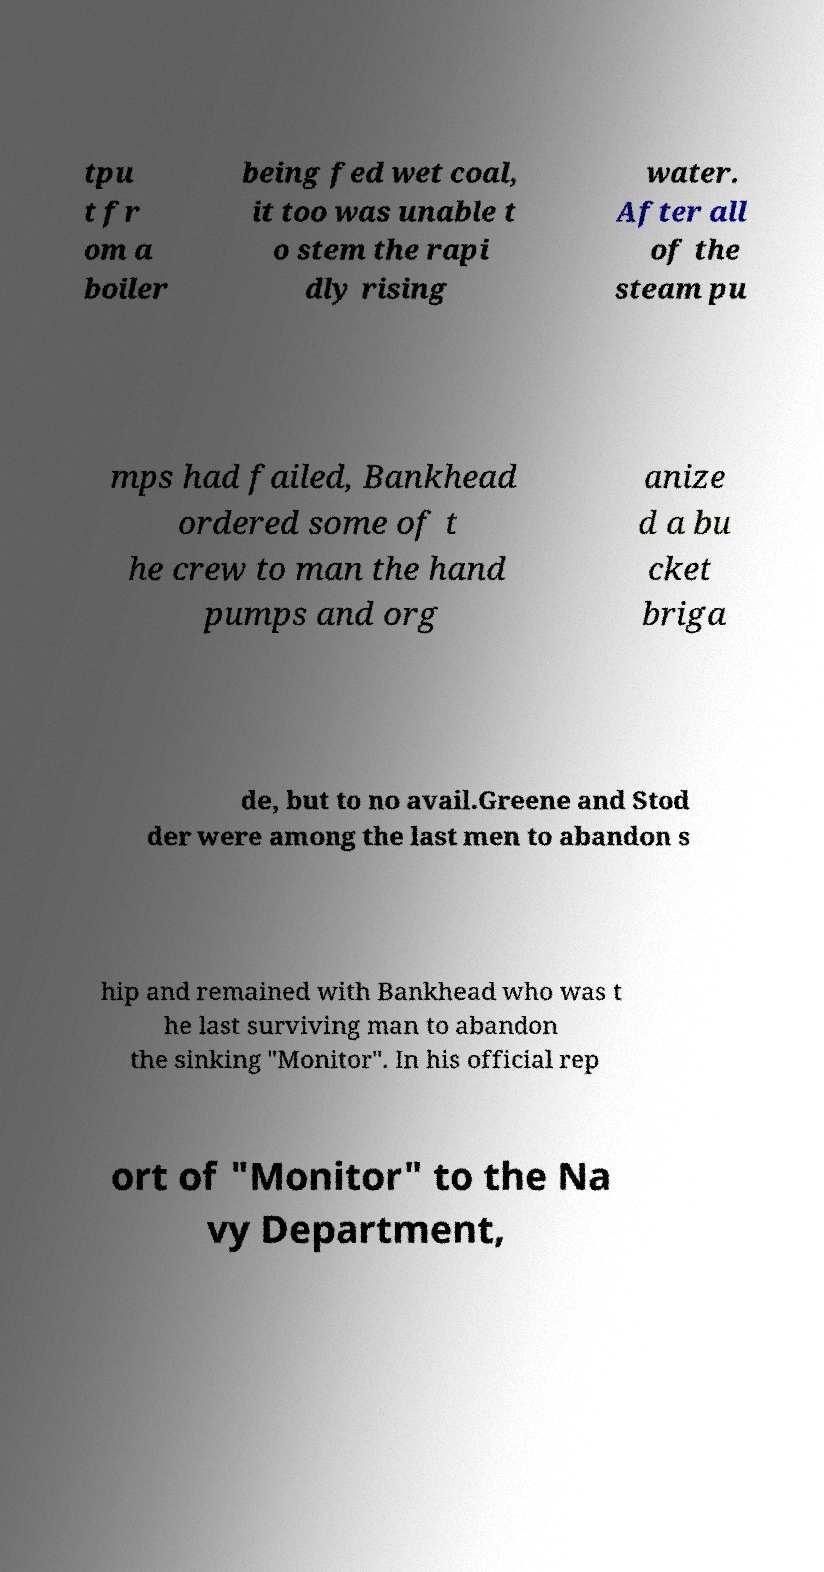Can you read and provide the text displayed in the image?This photo seems to have some interesting text. Can you extract and type it out for me? tpu t fr om a boiler being fed wet coal, it too was unable t o stem the rapi dly rising water. After all of the steam pu mps had failed, Bankhead ordered some of t he crew to man the hand pumps and org anize d a bu cket briga de, but to no avail.Greene and Stod der were among the last men to abandon s hip and remained with Bankhead who was t he last surviving man to abandon the sinking "Monitor". In his official rep ort of "Monitor" to the Na vy Department, 